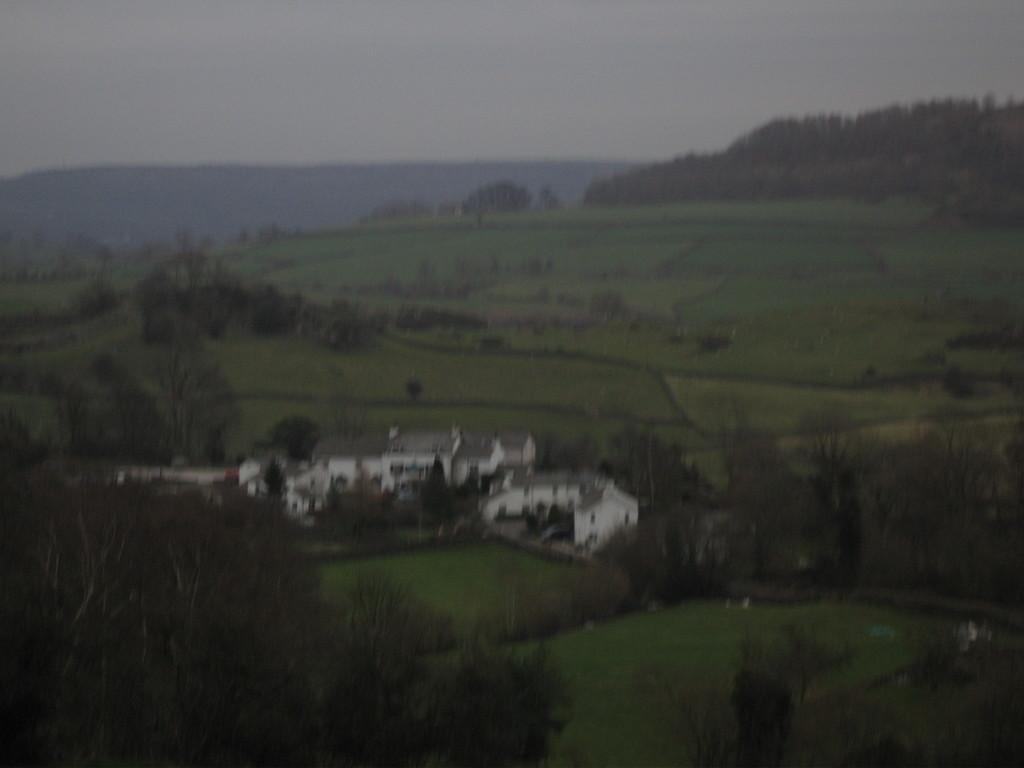What type of natural elements can be seen in the image? There are trees in the image. What type of man-made structures are present in the image? There are buildings in the image. What can be seen in the background of the image? The sky is visible in the background of the image. Is there a hydrant visible in the image? There is no hydrant present in the image. Can you see a volcano erupting in the background of the image? There is no volcano present in the image, and no eruption is depicted. 